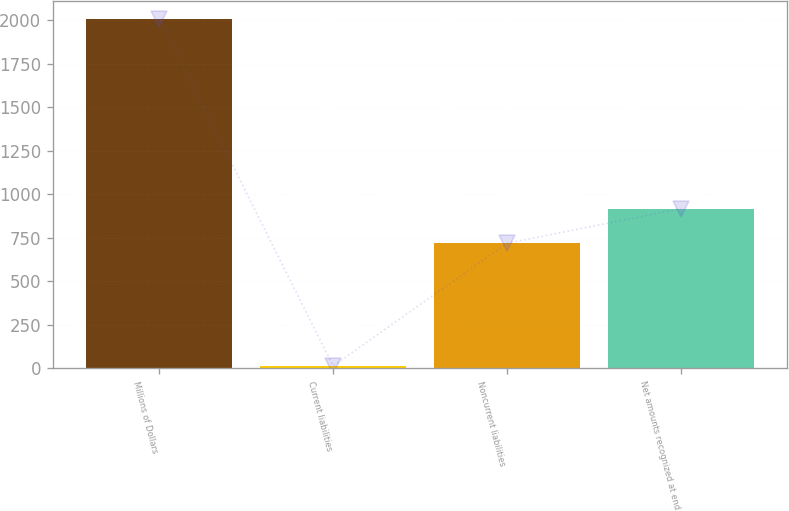Convert chart to OTSL. <chart><loc_0><loc_0><loc_500><loc_500><bar_chart><fcel>Millions of Dollars<fcel>Current liabilities<fcel>Noncurrent liabilities<fcel>Net amounts recognized at end<nl><fcel>2008<fcel>12<fcel>717<fcel>916.6<nl></chart> 